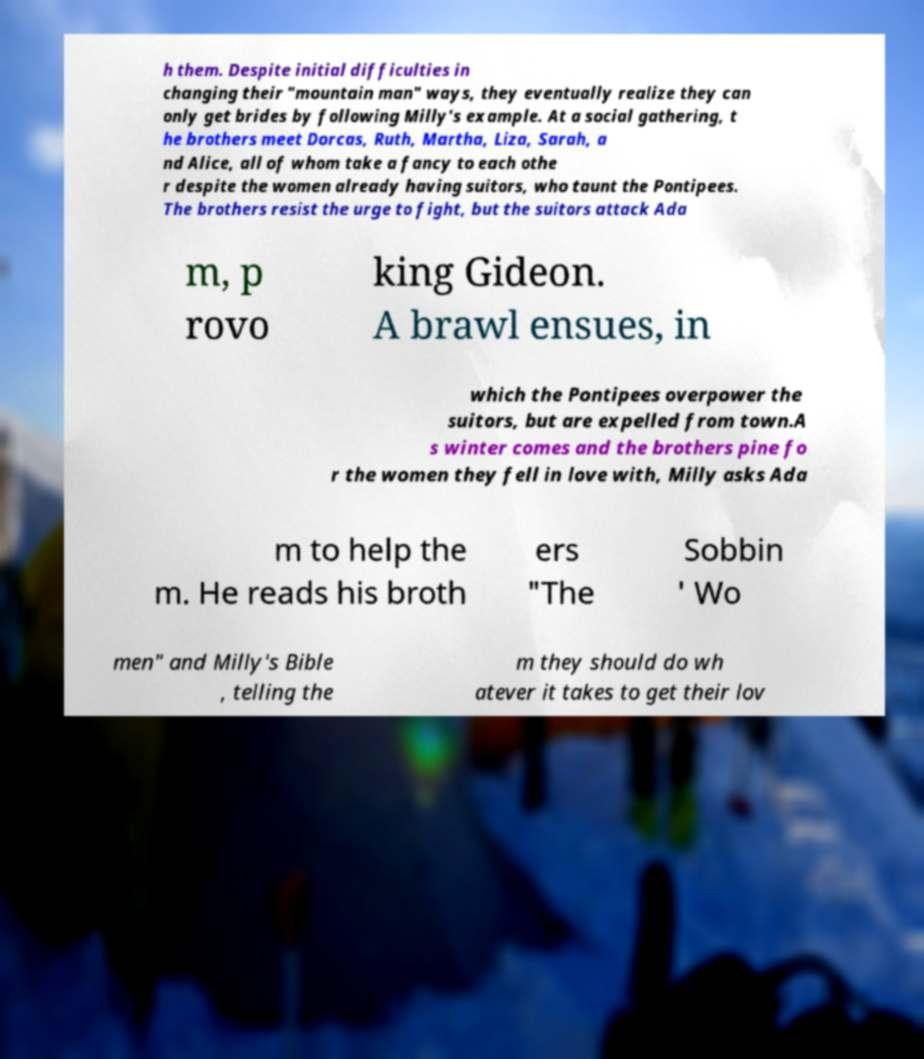Can you read and provide the text displayed in the image?This photo seems to have some interesting text. Can you extract and type it out for me? h them. Despite initial difficulties in changing their "mountain man" ways, they eventually realize they can only get brides by following Milly's example. At a social gathering, t he brothers meet Dorcas, Ruth, Martha, Liza, Sarah, a nd Alice, all of whom take a fancy to each othe r despite the women already having suitors, who taunt the Pontipees. The brothers resist the urge to fight, but the suitors attack Ada m, p rovo king Gideon. A brawl ensues, in which the Pontipees overpower the suitors, but are expelled from town.A s winter comes and the brothers pine fo r the women they fell in love with, Milly asks Ada m to help the m. He reads his broth ers "The Sobbin ' Wo men" and Milly's Bible , telling the m they should do wh atever it takes to get their lov 